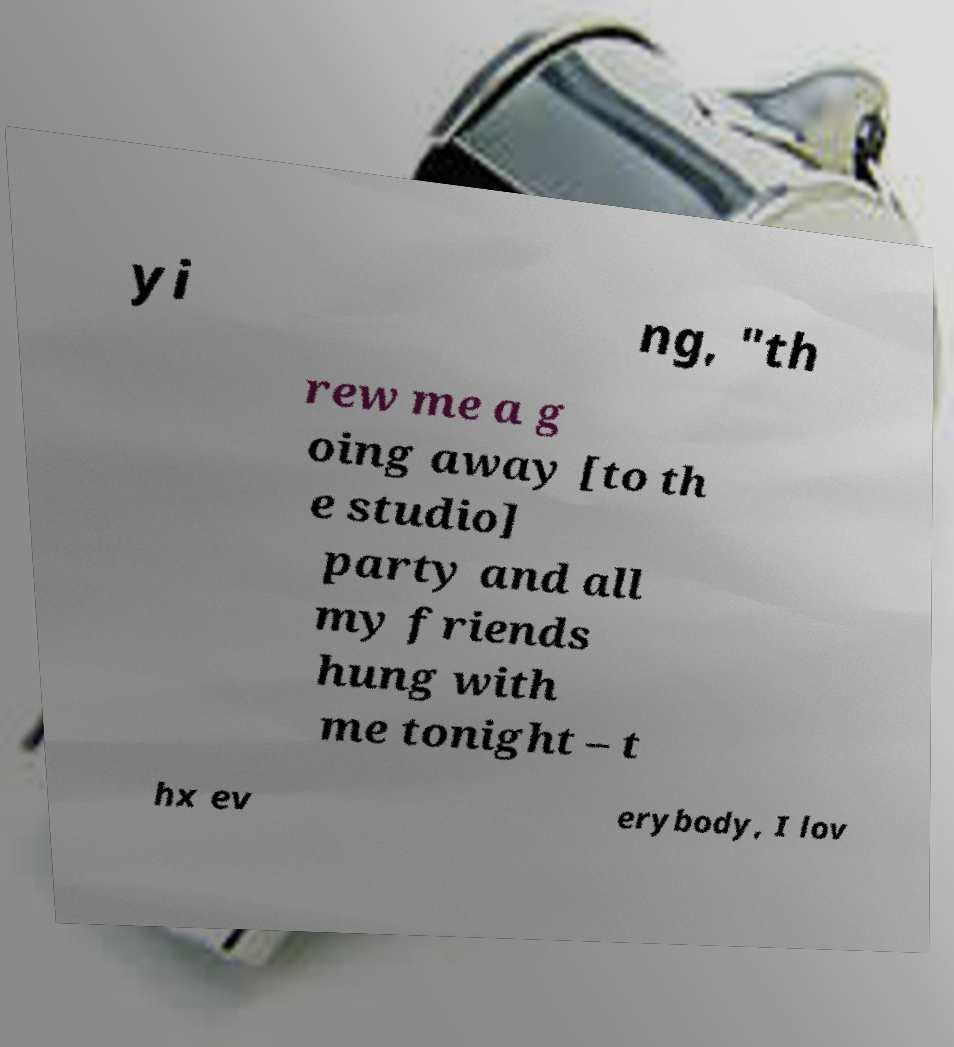I need the written content from this picture converted into text. Can you do that? yi ng, "th rew me a g oing away [to th e studio] party and all my friends hung with me tonight – t hx ev erybody, I lov 